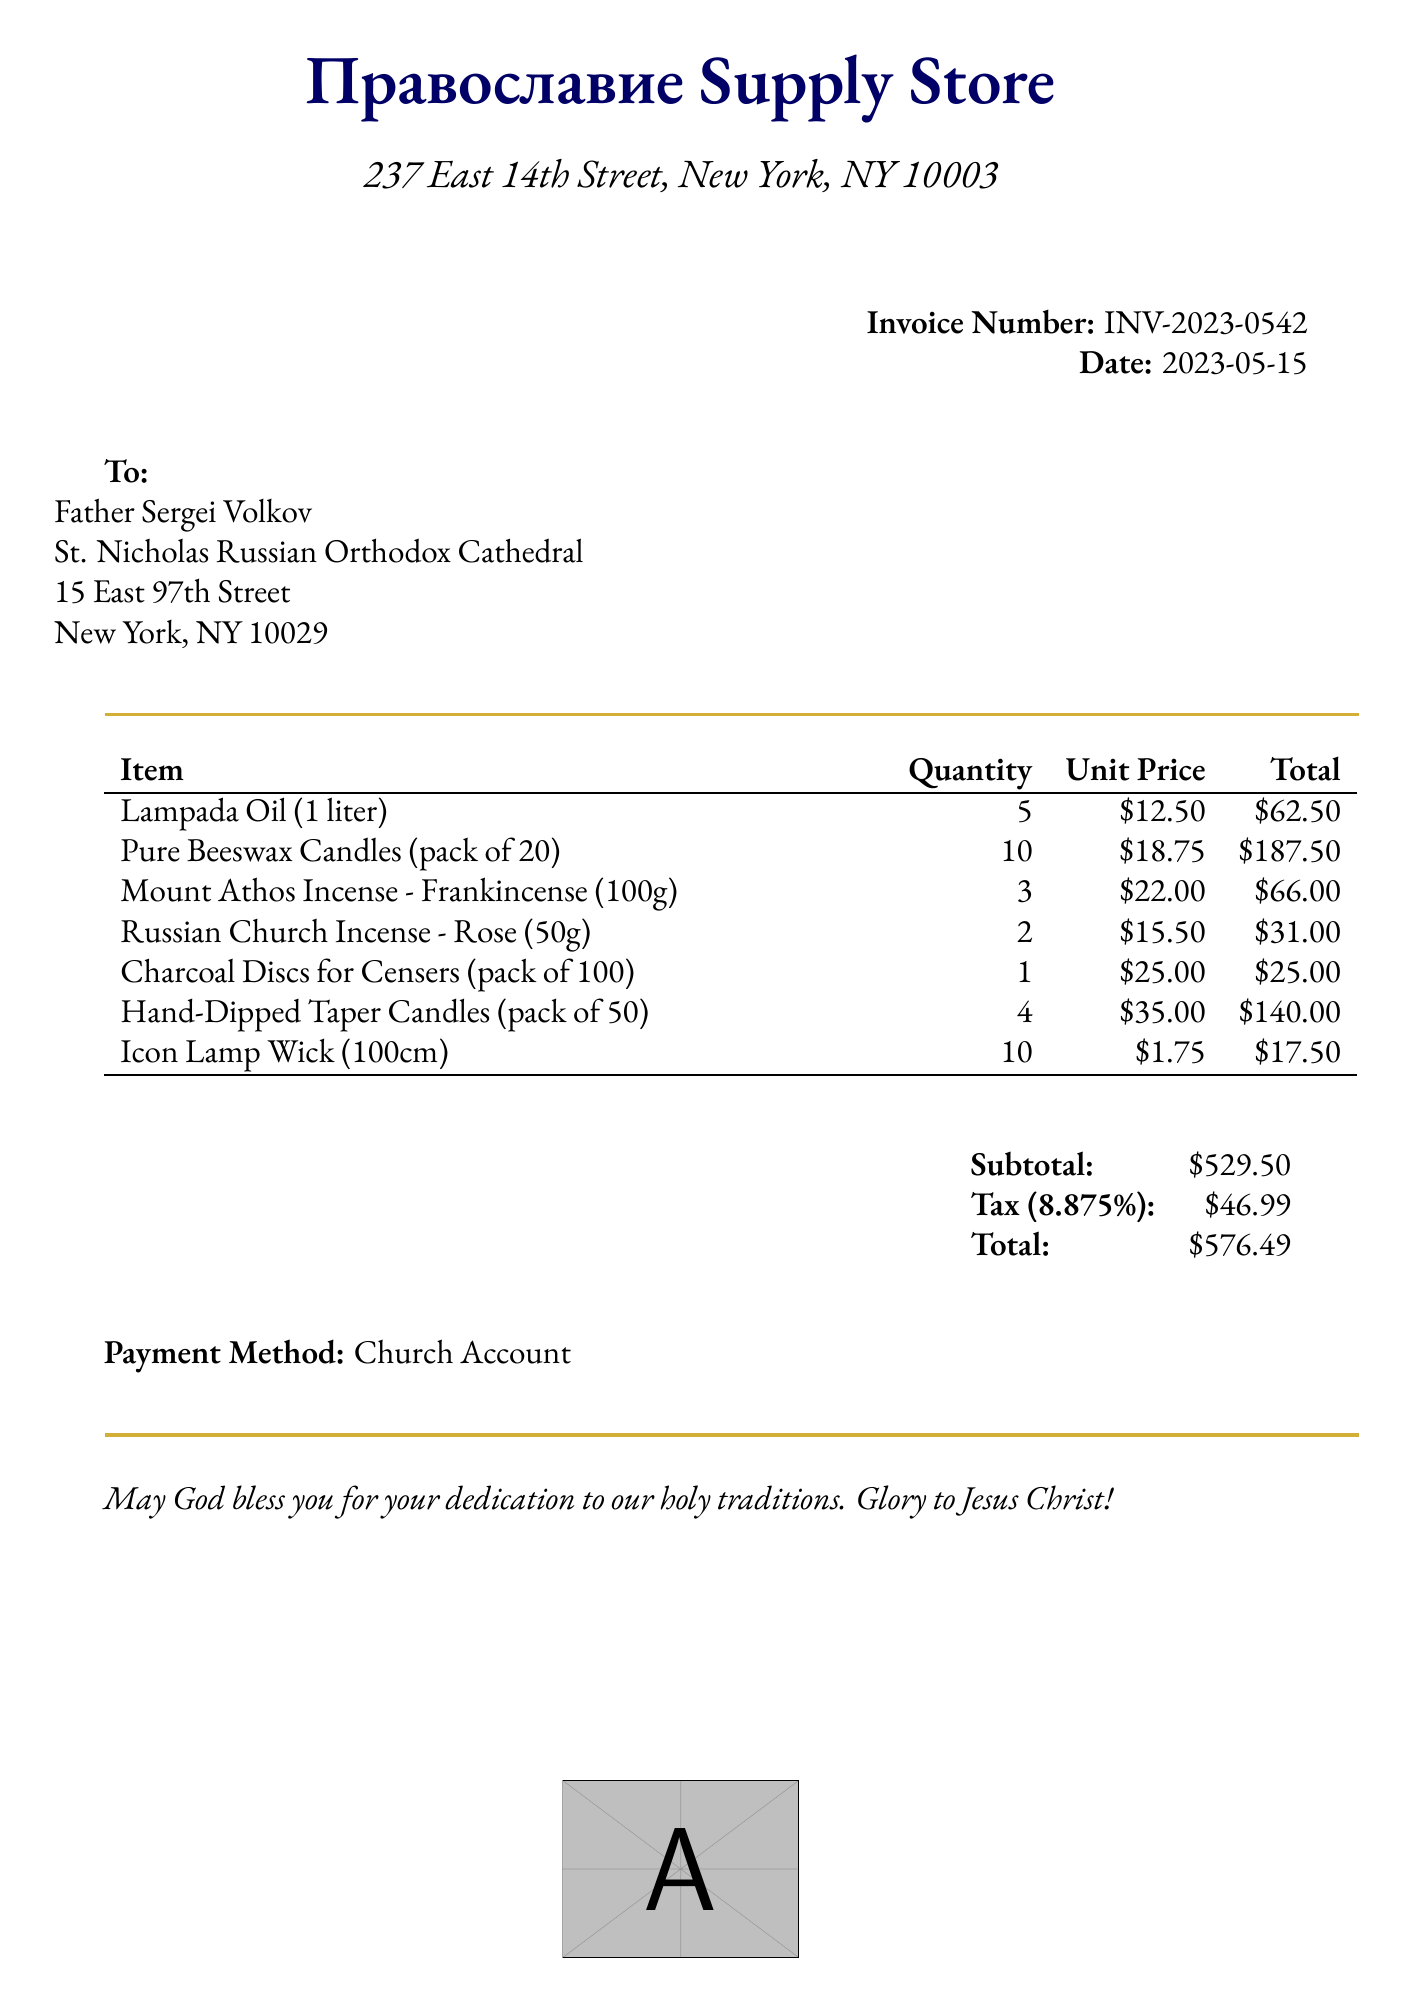What is the invoice number? The invoice number is specifically listed in the document under the invoice details.
Answer: INV-2023-0542 What is the total amount due? The total amount due is calculated as the subtotal plus the tax, clearly provided in the document.
Answer: $576.49 Who is the customer? The customer's name is mentioned at the top of the invoice, identifying the person who made the purchase.
Answer: Father Sergei Volkov What is the date of the invoice? The date is explicitly stated in the document, indicating when the transaction occurred.
Answer: 2023-05-15 How many packs of Pure Beeswax Candles were purchased? The quantity of Pure Beeswax Candles is detailed in the itemized list of products.
Answer: 10 What is the unit price of Icon Lamp Wick? The unit price can be found in the list of items, which shows the cost per individual item.
Answer: $1.75 What is the tax rate applied to the invoice? The tax rate is specified in the document, providing the percentage used for the calculation of the tax.
Answer: 8.875% What is the payment method for this invoice? The payment method is mentioned towards the end of the document, specifying how the customer intends to pay.
Answer: Church Account What is the subtotal of the items purchased? The subtotal is clearly indicated prior to tax and total calculations in the invoice.
Answer: $529.50 